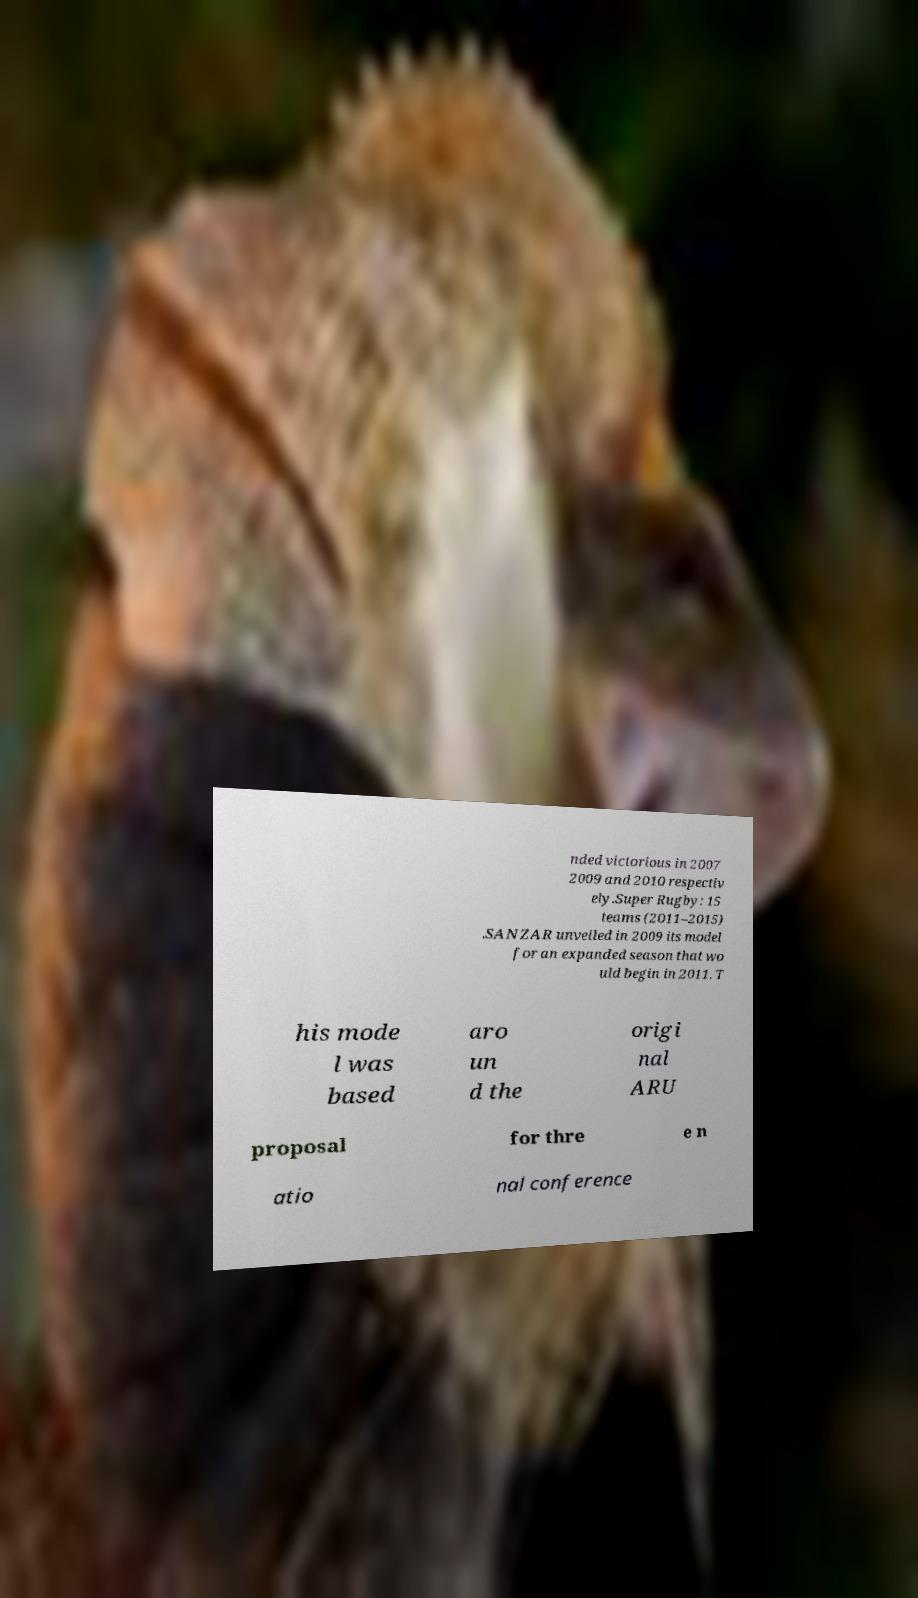What messages or text are displayed in this image? I need them in a readable, typed format. nded victorious in 2007 2009 and 2010 respectiv ely.Super Rugby: 15 teams (2011–2015) .SANZAR unveiled in 2009 its model for an expanded season that wo uld begin in 2011. T his mode l was based aro un d the origi nal ARU proposal for thre e n atio nal conference 